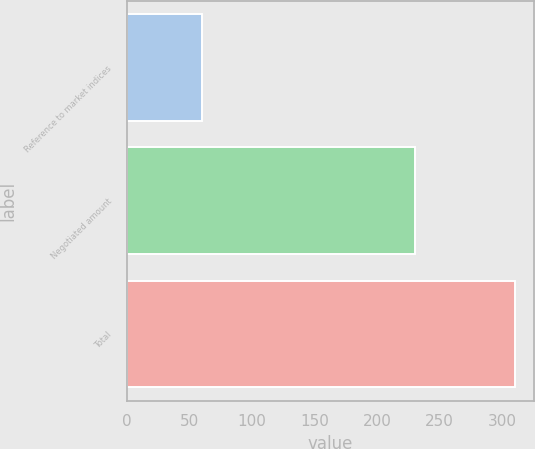Convert chart to OTSL. <chart><loc_0><loc_0><loc_500><loc_500><bar_chart><fcel>Reference to market indices<fcel>Negotiated amount<fcel>Total<nl><fcel>60<fcel>230<fcel>310<nl></chart> 